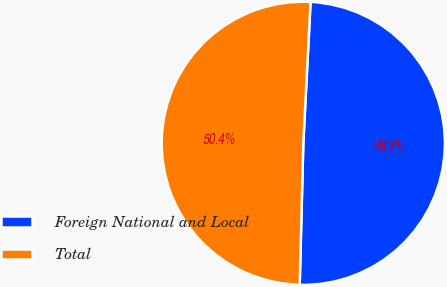<chart> <loc_0><loc_0><loc_500><loc_500><pie_chart><fcel>Foreign National and Local<fcel>Total<nl><fcel>49.59%<fcel>50.41%<nl></chart> 